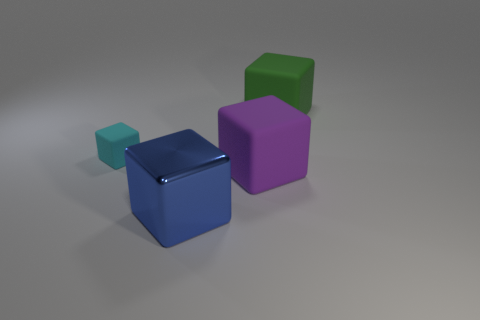There is a big matte cube that is left of the matte cube that is behind the tiny cyan matte cube; are there any cubes that are on the right side of it? Based on the image, there are no cubes positioned to the right of the large cube mentioned in the question. To clarify, visually from the vantage point presented, the tiny cyan cube is centrally located with respect to the horizontal plane, the blue cube is behind and to the right of it, and the purple cube is to the left of the cyan cube. There aren't any cubes situated to the right of the purple cube. 